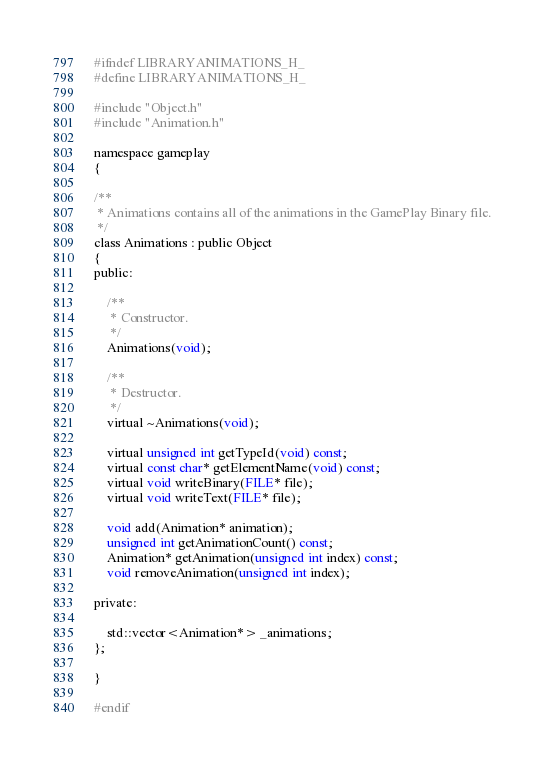<code> <loc_0><loc_0><loc_500><loc_500><_C_>#ifndef LIBRARYANIMATIONS_H_
#define LIBRARYANIMATIONS_H_

#include "Object.h"
#include "Animation.h"

namespace gameplay
{

/**
 * Animations contains all of the animations in the GamePlay Binary file.
 */
class Animations : public Object
{
public:

    /**
     * Constructor.
     */
    Animations(void);

    /**
     * Destructor.
     */
    virtual ~Animations(void);

    virtual unsigned int getTypeId(void) const;
    virtual const char* getElementName(void) const;
    virtual void writeBinary(FILE* file);
    virtual void writeText(FILE* file);

    void add(Animation* animation);
    unsigned int getAnimationCount() const;
    Animation* getAnimation(unsigned int index) const;
    void removeAnimation(unsigned int index);

private:

    std::vector<Animation*> _animations;
};

}

#endif
</code> 